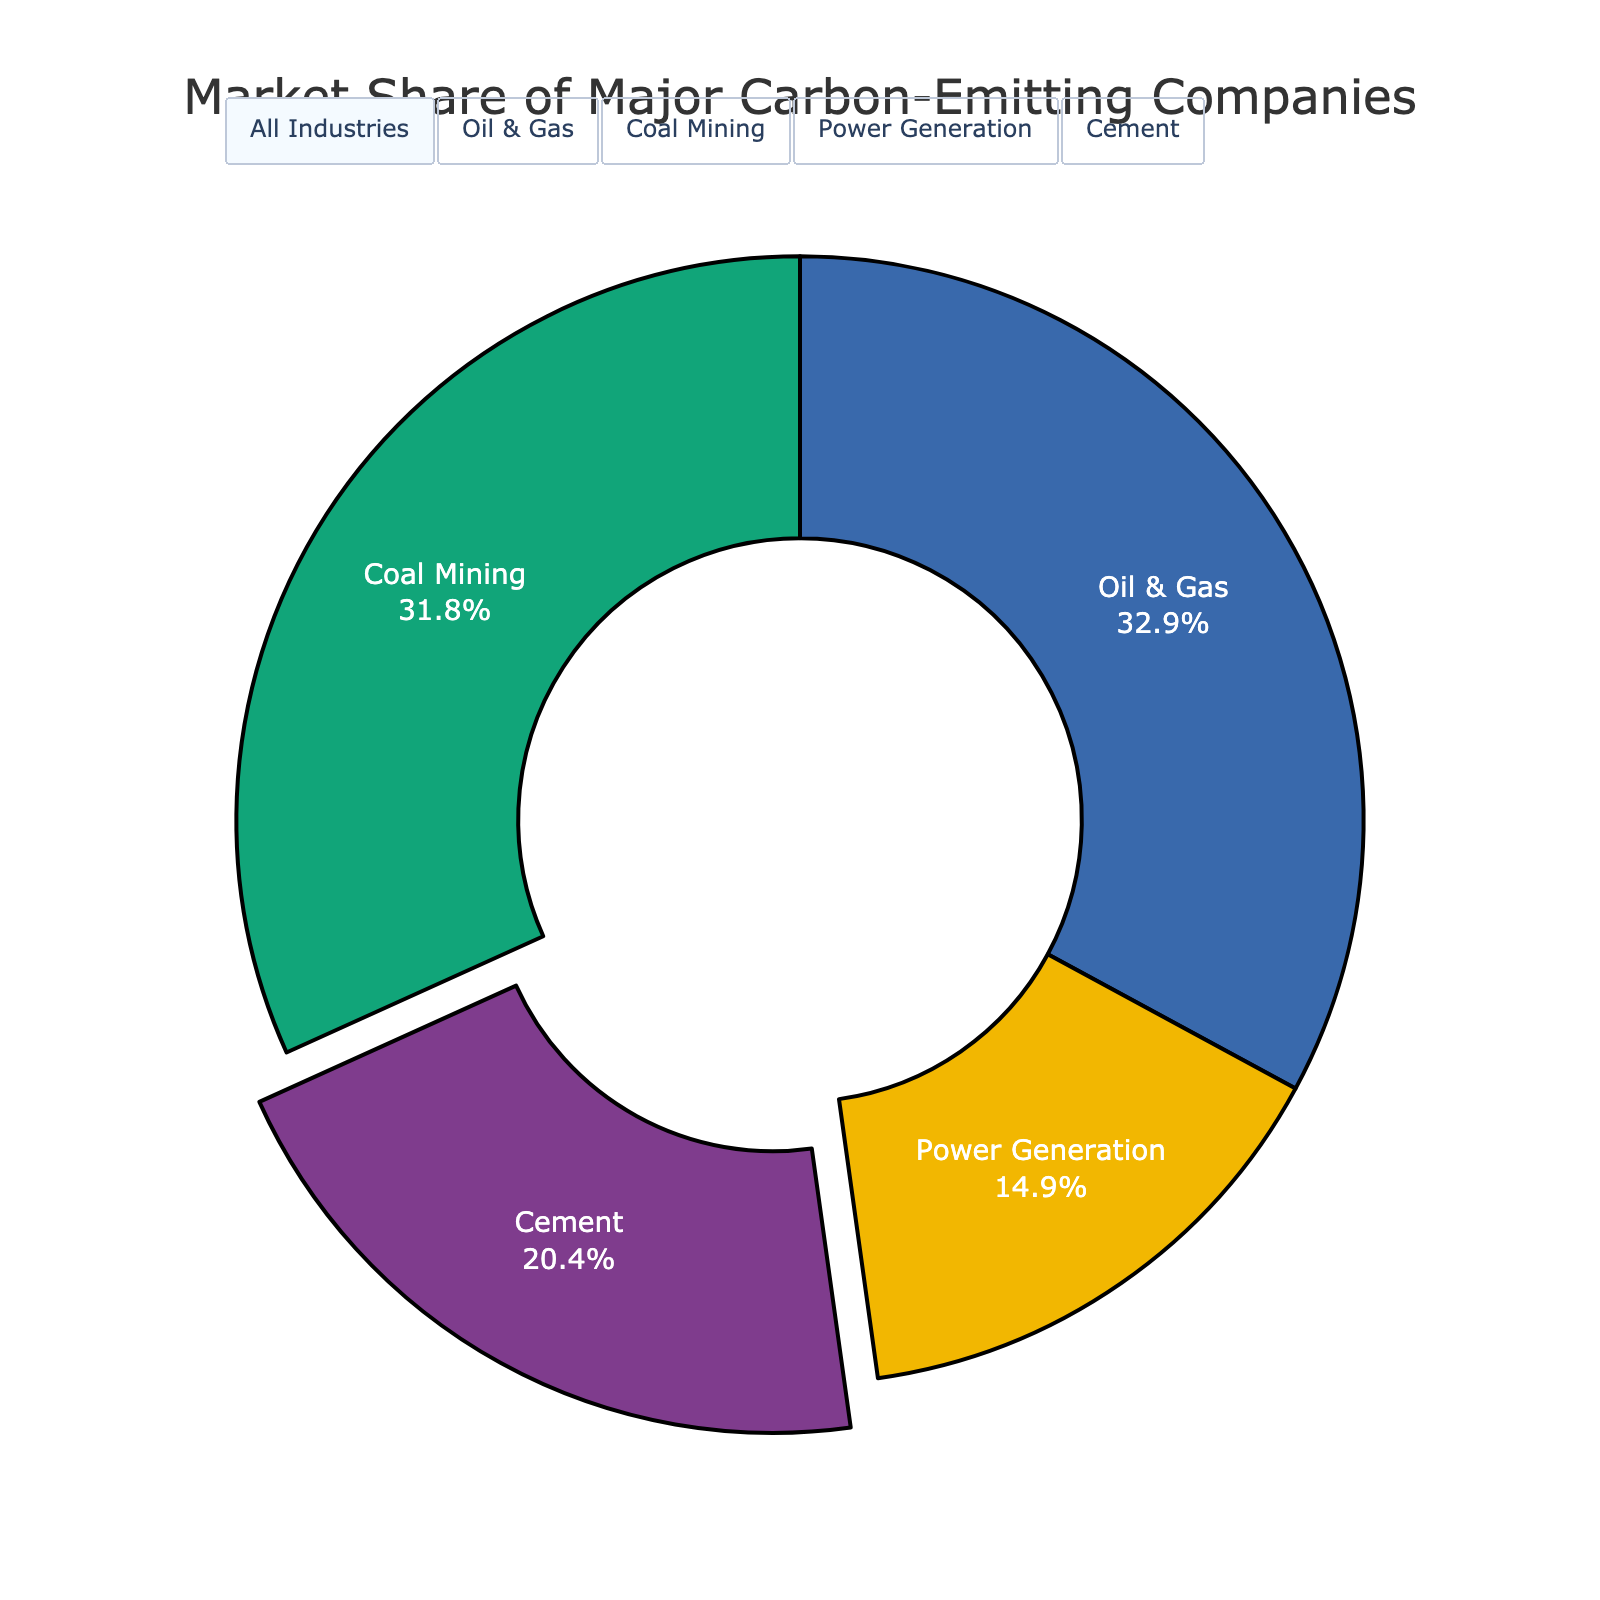Which industry has the largest market share of major carbon-emitting companies? By referring to the pie chart, the segment for 'Oil & Gas' industry looks the largest in the pie chart.
Answer: Oil & Gas What is the combined market share of Chevron and Shell in the Oil & Gas industry? From the figure, Chevron's market share is 11.2% and Shell's market share is 10.8%. Summing these two values gives 11.2 + 10.8 = 22%.
Answer: 22% How does the market share of China Shenhua Energy compare to Peabody Energy in the Coal Mining industry? The pie chart annotations show that China Shenhua Energy has a market share of 15.3%, while Peabody Energy has a market share of 8.6%. Hence, China Shenhua Energy's share is larger.
Answer: China Shenhua Energy > Peabody Energy What's the difference between the market shares of ExxonMobil and BP in the Oil & Gas industry? ExxonMobil holds a market share of 14.5% while BP has a market share of 9.7%. The difference can be calculated as 14.5 - 9.7 = 4.8%.
Answer: 4.8% Which company in the Cement industry has the smallest market share? Examining the Cement industry section of the annotations, HeidelbergCement has the smallest market share at 5.8%.
Answer: HeidelbergCement Are there more industries with a market share above 10%? Reviewing the pie chart and annotations, the companies with shares above 10% are ExxonMobil, Chevron, Shell, and BP in Oil & Gas as well as China Shenhua Energy and Coal India Limited in Coal Mining, making a total of 6. Industries with shares above 10% belong to Oil & Gas and Coal Mining.
Answer: Yes Compare the market share of the largest energy company in the Power Generation sector with that of LafargeHolcim in the Cement industry. The largest market share in Power Generation is held by China Huaneng Group at 6.5%, while LafargeHolcim in the Cement industry holds 8.4%. So, LafargeHolcim has a larger share.
Answer: LafargeHolcim > China Huaneng Group What's the market share of companies in the Power Generation industry combined? Adding up the market shares in the Power Generation industry gives China Huaneng Group (6.5%) + Électricité de France (5.8%) + Duke Energy (4.7%) + Southern Company (3.9%), totaling 20.9%.
Answer: 20.9% Between the Oil & Gas and Cement industries, which has more companies listed in the chart? According to the pie chart annotations, the Oil & Gas industry lists ExxonMobil, Chevron, Shell, and BP (4 companies), whereas the Cement industry lists LafargeHolcim, Anhui Conch, CNBM, and HeidelbergCement (4 companies). Both industries have the same number of companies listed.
Answer: Equal What's the sum of the market shares of the top two companies in the Coal Mining industry? The top two companies in the Coal Mining industry are China Shenhua Energy (15.3%) and Coal India Limited (12.8%). Summing these two values gives 15.3 + 12.8 = 28.1%.
Answer: 28.1% 